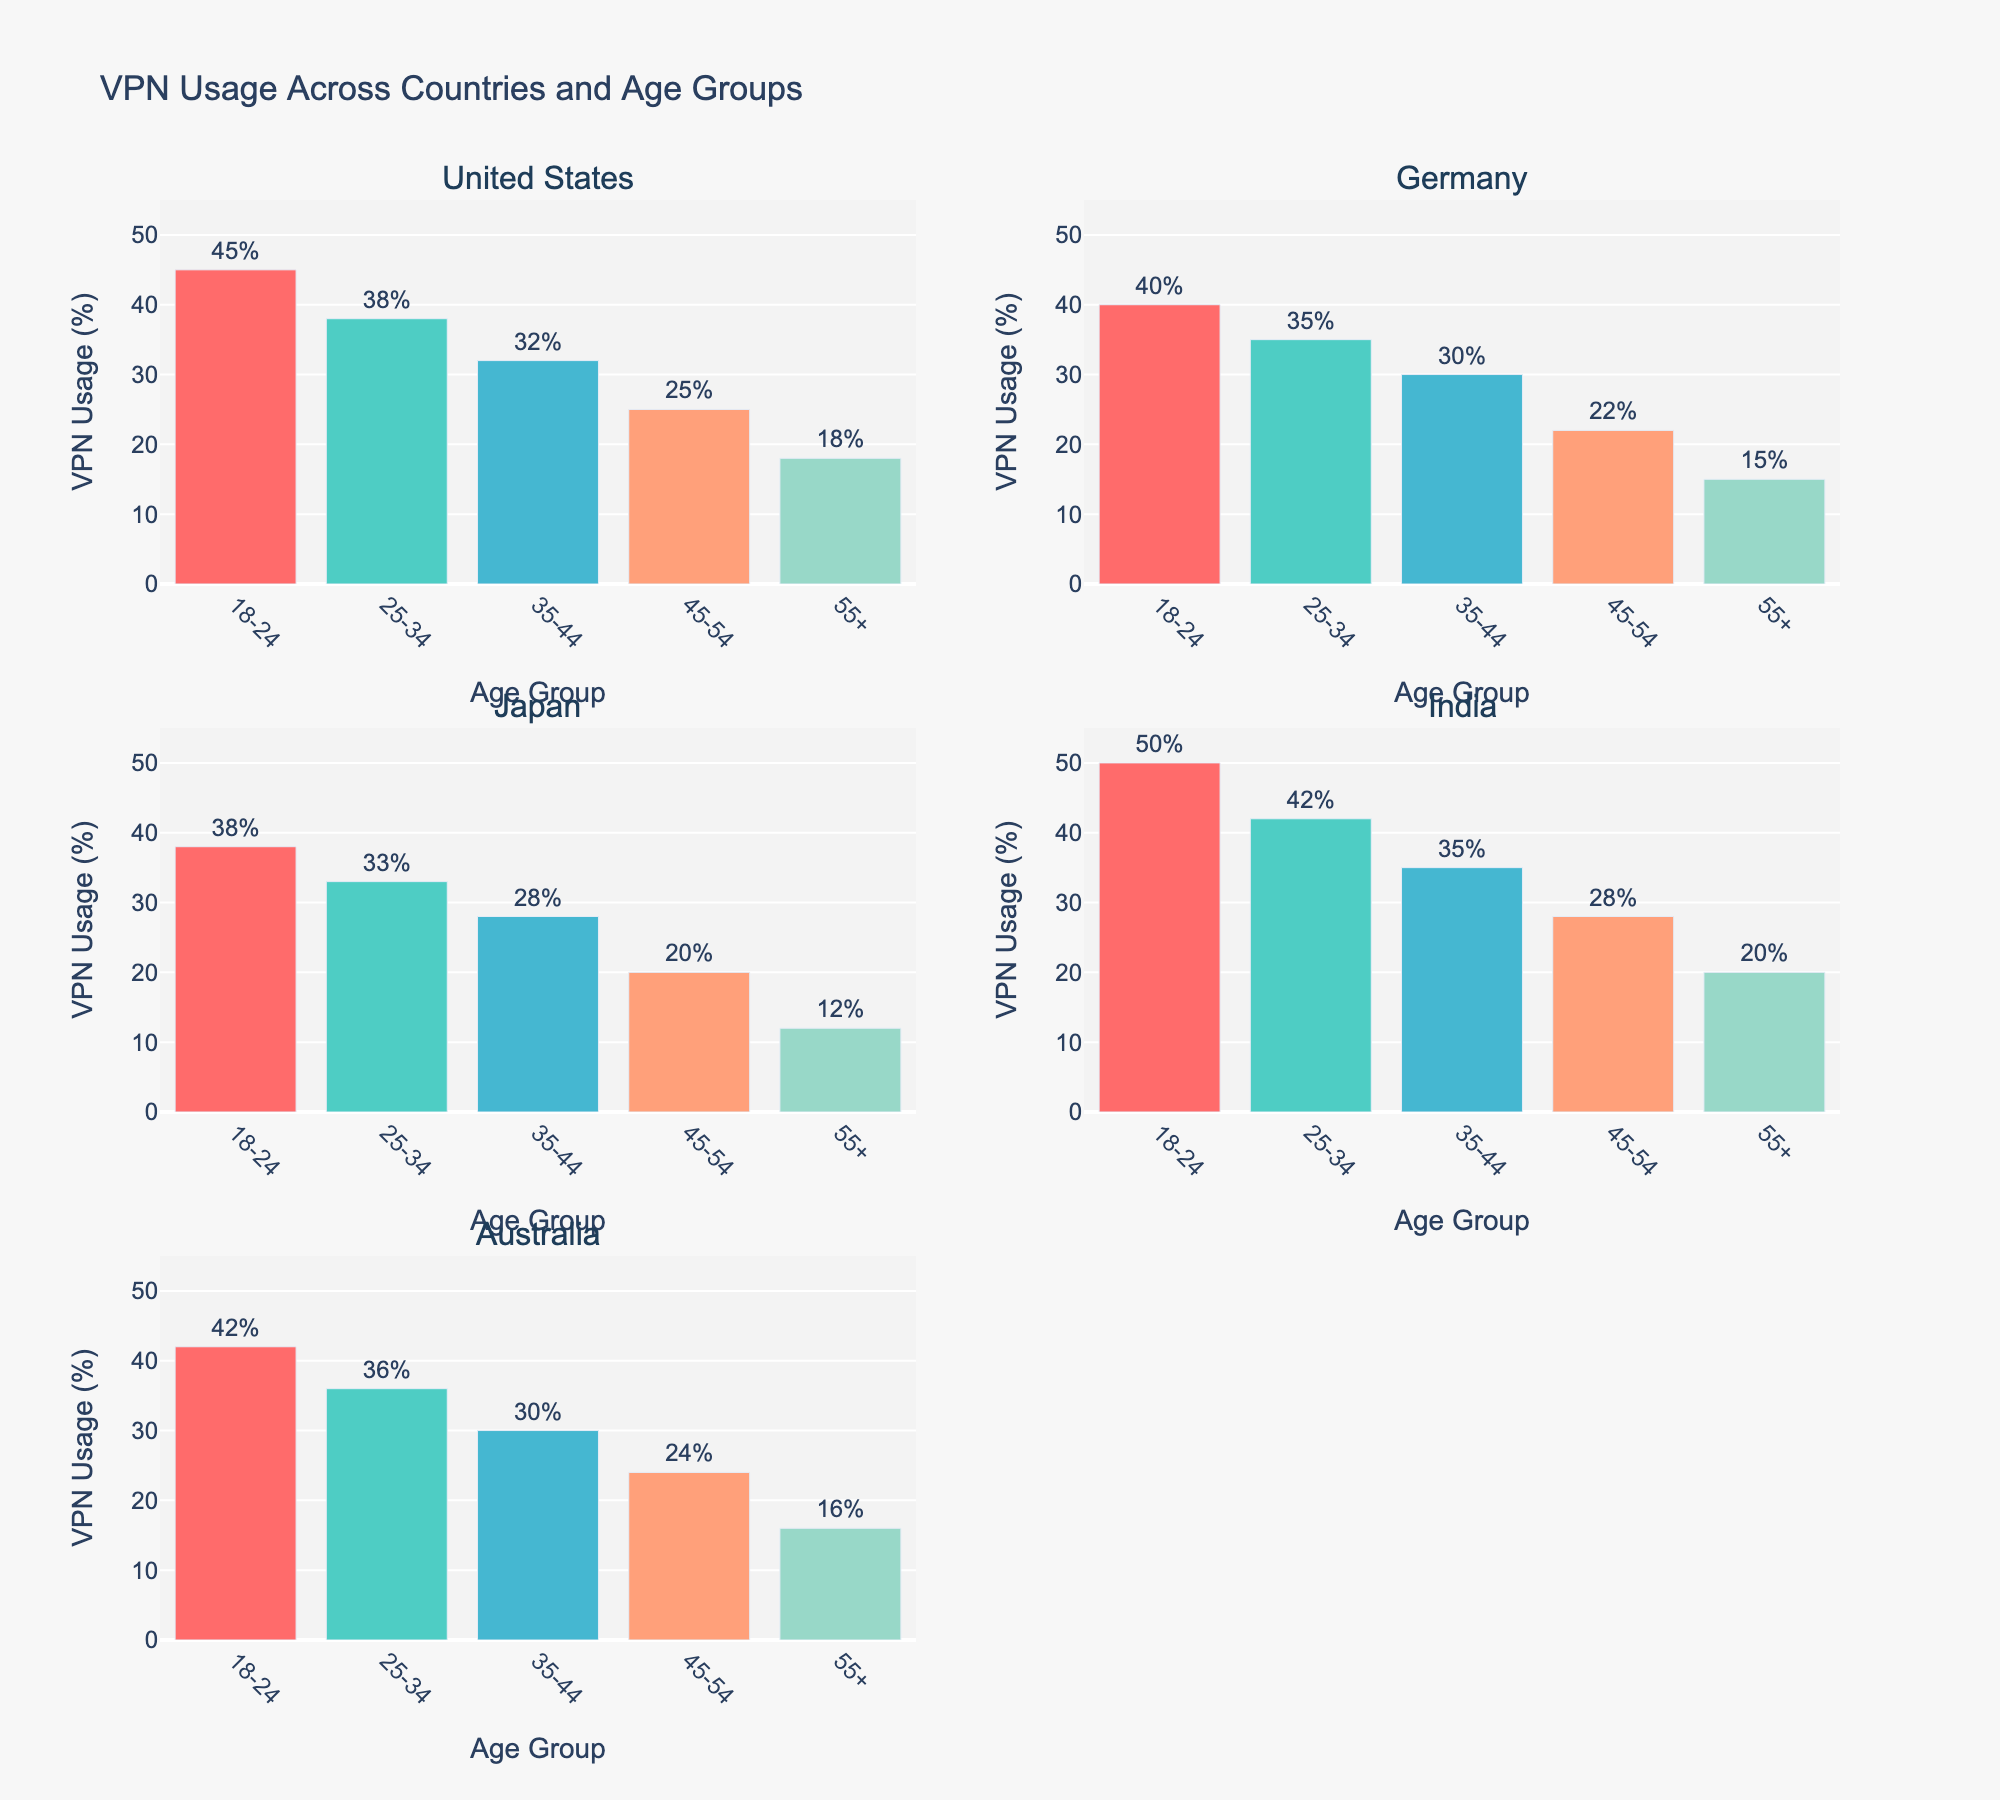What is the highest VPN usage percentage across all age groups in the United States? Look for the highest bar in the subplot for the United States. The highest bar represents the 18-24 age group at 45%.
Answer: 45% Which country has the lowest VPN usage percentage for the 55+ age group? Look for the bars that represent the 55+ age group in each subplot. The lowest bar is in Japan, with 12%.
Answer: Japan What is the title of the overall figure? The title is located at the top center of the figure. It reads "VPN Usage Across Countries and Age Groups."
Answer: VPN Usage Across Countries and Age Groups How does VPN usage in the 25-34 age group in India compare to that in Australia? Compare the height of the bars for the 25-34 age group in the subplots for India and Australia. India has a higher usage at 42% compared to Australia's 36%.
Answer: India (42%) > Australia (36%) What is the average VPN usage percentage for all age groups in Germany? Add up the VPN usage percentages for all age groups in Germany and divide by the number of age groups: (40 + 35 + 30 + 22 + 15) / 5 = 28.4%.
Answer: 28.4% Which country's VPN usage decreases the most significantly from the 18-24 age group to the 55+ age group? Calculate the difference between the 18-24 age group and the 55+ age group for each country. United States: 45-18=27, Germany: 40-15=25, Japan: 38-12=26, India: 50-20=30, Australia: 42-16=26. India decreases by 30%, which is the highest.
Answer: India (30%) Which age group generally shows the highest VPN usage across all countries? Look at the bars representing each age group across all subplots. The highest bars for most countries are in the 18-24 age group.
Answer: 18-24 How does VPN usage in the 35-44 age group in the United States compare to the same age group in Germany? Compare the bars representing the 35-44 age group in the subplots for the United States and Germany. The United States has 32%, while Germany has 30%.
Answer: United States (32%) > Germany (30%) What is the median VPN usage percentage in Japan across all age groups? Arrange the VPN usage percentages for Japan in order: 12, 20, 28, 33, 38. The middle value (3rd) is 28.
Answer: 28% What color is used to represent the 25-34 age group in the figure? Look for the bar colors and corresponding age group in the bar traces. The color for the 25-34 age group is identified as #4ECDC4 (a shade of turquoise).
Answer: turquoise 